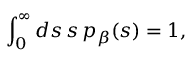<formula> <loc_0><loc_0><loc_500><loc_500>\int _ { 0 } ^ { \infty } d s \, s \, p _ { \beta } ( s ) = 1 ,</formula> 